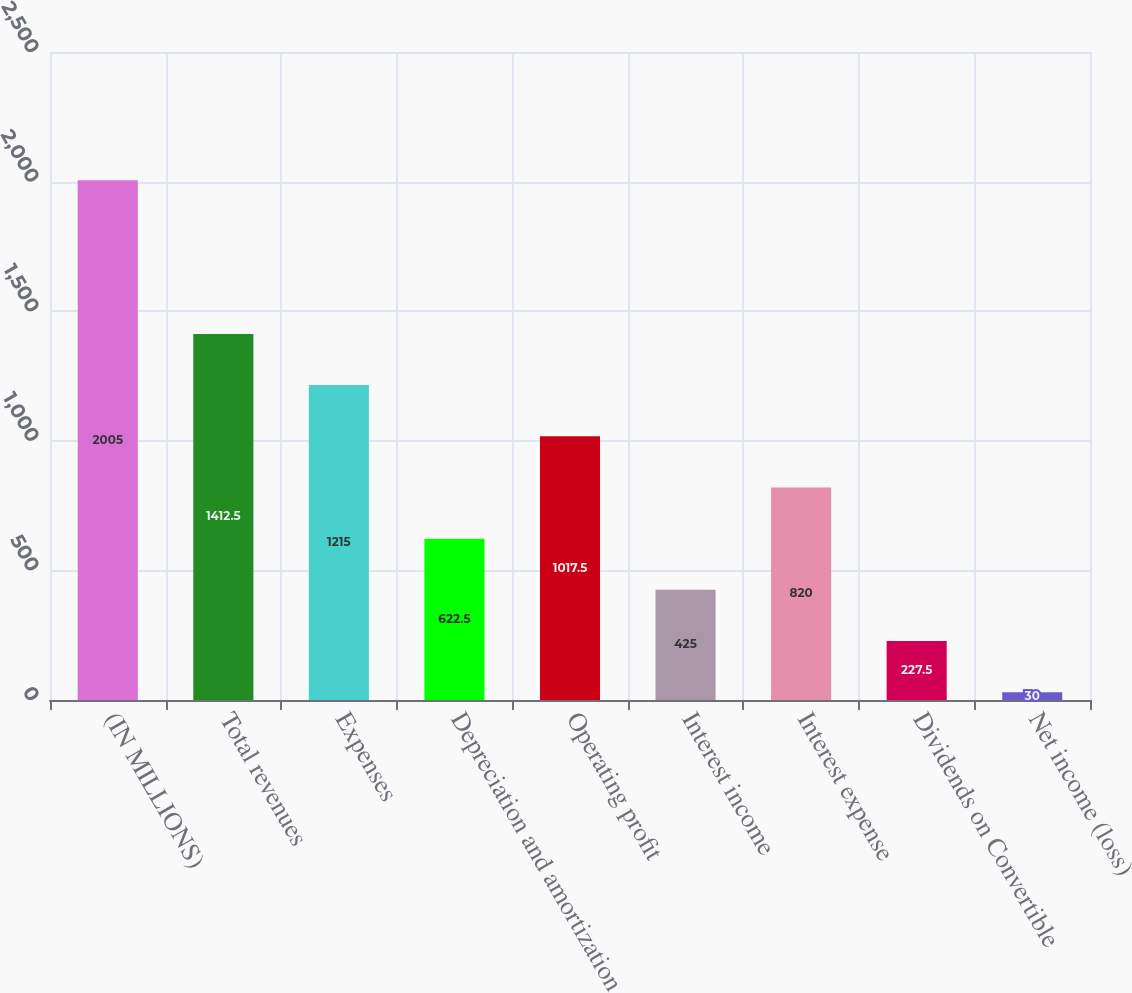Convert chart to OTSL. <chart><loc_0><loc_0><loc_500><loc_500><bar_chart><fcel>(IN MILLIONS)<fcel>Total revenues<fcel>Expenses<fcel>Depreciation and amortization<fcel>Operating profit<fcel>Interest income<fcel>Interest expense<fcel>Dividends on Convertible<fcel>Net income (loss)<nl><fcel>2005<fcel>1412.5<fcel>1215<fcel>622.5<fcel>1017.5<fcel>425<fcel>820<fcel>227.5<fcel>30<nl></chart> 